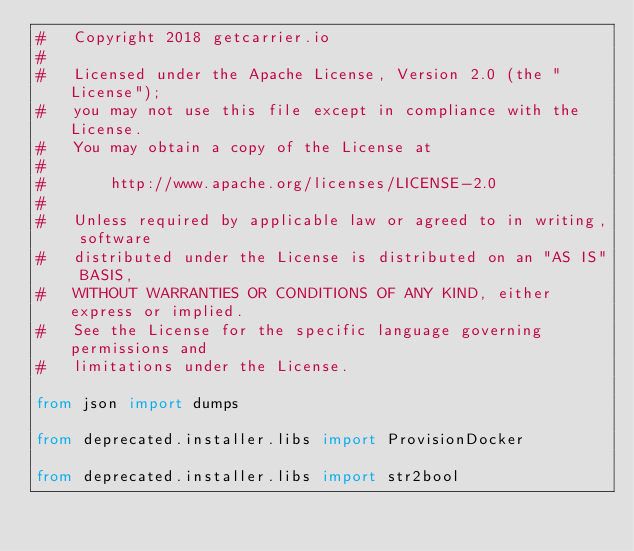Convert code to text. <code><loc_0><loc_0><loc_500><loc_500><_Python_>#   Copyright 2018 getcarrier.io
#
#   Licensed under the Apache License, Version 2.0 (the "License");
#   you may not use this file except in compliance with the License.
#   You may obtain a copy of the License at
#
#       http://www.apache.org/licenses/LICENSE-2.0
#
#   Unless required by applicable law or agreed to in writing, software
#   distributed under the License is distributed on an "AS IS" BASIS,
#   WITHOUT WARRANTIES OR CONDITIONS OF ANY KIND, either express or implied.
#   See the License for the specific language governing permissions and
#   limitations under the License.

from json import dumps

from deprecated.installer.libs import ProvisionDocker

from deprecated.installer.libs import str2bool</code> 